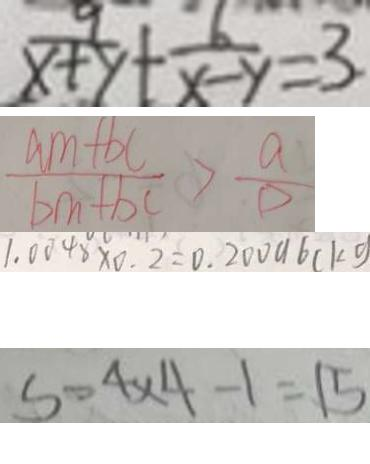Convert formula to latex. <formula><loc_0><loc_0><loc_500><loc_500>\frac { 9 } { x + y } + \frac { 6 } { x - y } = 3 . 
 \frac { a m + b c } { b m + b c } > \frac { a } { D } 
 1 . 0 0 4 8 \times 0 . 2 = 0 . 2 0 0 9 6 ( k g 
 S = 4 \times 4 - 1 = 1 5</formula> 